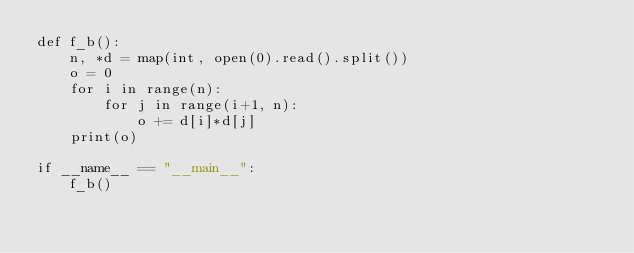Convert code to text. <code><loc_0><loc_0><loc_500><loc_500><_Python_>def f_b():
    n, *d = map(int, open(0).read().split())
    o = 0
    for i in range(n):
        for j in range(i+1, n):
            o += d[i]*d[j]
    print(o)

if __name__ == "__main__":
    f_b()
</code> 